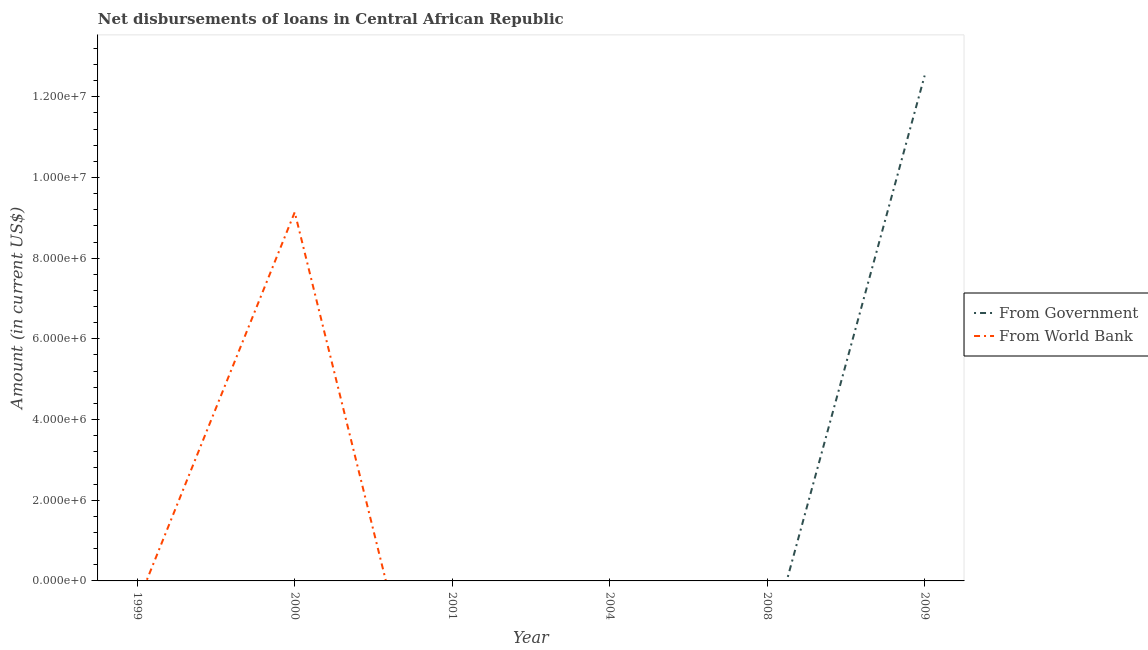How many different coloured lines are there?
Provide a short and direct response. 2. What is the net disbursements of loan from world bank in 2004?
Give a very brief answer. 0. Across all years, what is the maximum net disbursements of loan from world bank?
Give a very brief answer. 9.14e+06. What is the total net disbursements of loan from world bank in the graph?
Keep it short and to the point. 9.14e+06. What is the difference between the net disbursements of loan from world bank in 2009 and the net disbursements of loan from government in 2000?
Make the answer very short. 0. What is the average net disbursements of loan from world bank per year?
Your response must be concise. 1.52e+06. What is the difference between the highest and the lowest net disbursements of loan from world bank?
Your answer should be compact. 9.14e+06. Does the net disbursements of loan from government monotonically increase over the years?
Give a very brief answer. No. Is the net disbursements of loan from world bank strictly greater than the net disbursements of loan from government over the years?
Your answer should be very brief. No. How many lines are there?
Give a very brief answer. 2. How many years are there in the graph?
Provide a succinct answer. 6. How many legend labels are there?
Provide a short and direct response. 2. What is the title of the graph?
Keep it short and to the point. Net disbursements of loans in Central African Republic. What is the label or title of the Y-axis?
Offer a terse response. Amount (in current US$). What is the Amount (in current US$) in From Government in 2000?
Your response must be concise. 0. What is the Amount (in current US$) of From World Bank in 2000?
Your response must be concise. 9.14e+06. What is the Amount (in current US$) of From Government in 2001?
Give a very brief answer. 0. What is the Amount (in current US$) in From World Bank in 2004?
Keep it short and to the point. 0. What is the Amount (in current US$) of From Government in 2008?
Offer a very short reply. 0. What is the Amount (in current US$) in From World Bank in 2008?
Provide a short and direct response. 0. What is the Amount (in current US$) of From Government in 2009?
Ensure brevity in your answer.  1.25e+07. What is the Amount (in current US$) in From World Bank in 2009?
Offer a very short reply. 0. Across all years, what is the maximum Amount (in current US$) of From Government?
Make the answer very short. 1.25e+07. Across all years, what is the maximum Amount (in current US$) in From World Bank?
Provide a short and direct response. 9.14e+06. Across all years, what is the minimum Amount (in current US$) in From World Bank?
Keep it short and to the point. 0. What is the total Amount (in current US$) in From Government in the graph?
Provide a succinct answer. 1.25e+07. What is the total Amount (in current US$) in From World Bank in the graph?
Make the answer very short. 9.14e+06. What is the average Amount (in current US$) of From Government per year?
Make the answer very short. 2.09e+06. What is the average Amount (in current US$) in From World Bank per year?
Make the answer very short. 1.52e+06. What is the difference between the highest and the lowest Amount (in current US$) in From Government?
Keep it short and to the point. 1.25e+07. What is the difference between the highest and the lowest Amount (in current US$) of From World Bank?
Keep it short and to the point. 9.14e+06. 